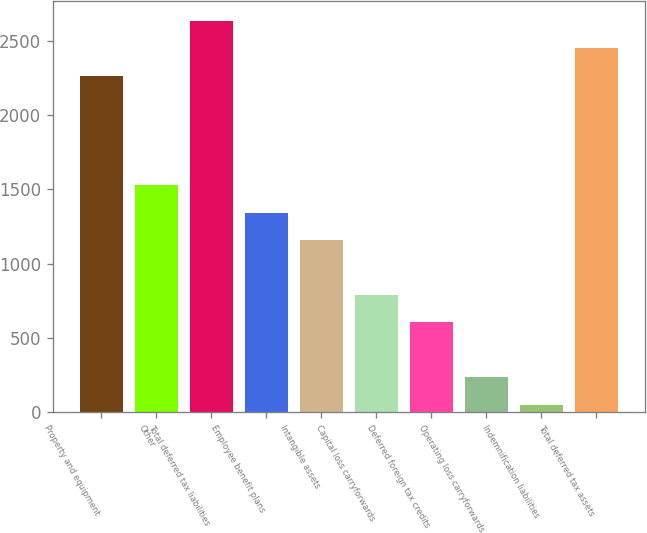Convert chart to OTSL. <chart><loc_0><loc_0><loc_500><loc_500><bar_chart><fcel>Property and equipment<fcel>Other<fcel>Total deferred tax liabilities<fcel>Employee benefit plans<fcel>Intangible assets<fcel>Capital loss carryforwards<fcel>Deferred foreign tax credits<fcel>Operating loss carryforwards<fcel>Indemnification liabilities<fcel>Total deferred tax assets<nl><fcel>2264.8<fcel>1526.4<fcel>2634<fcel>1341.8<fcel>1157.2<fcel>788<fcel>603.4<fcel>234.2<fcel>49.6<fcel>2449.4<nl></chart> 